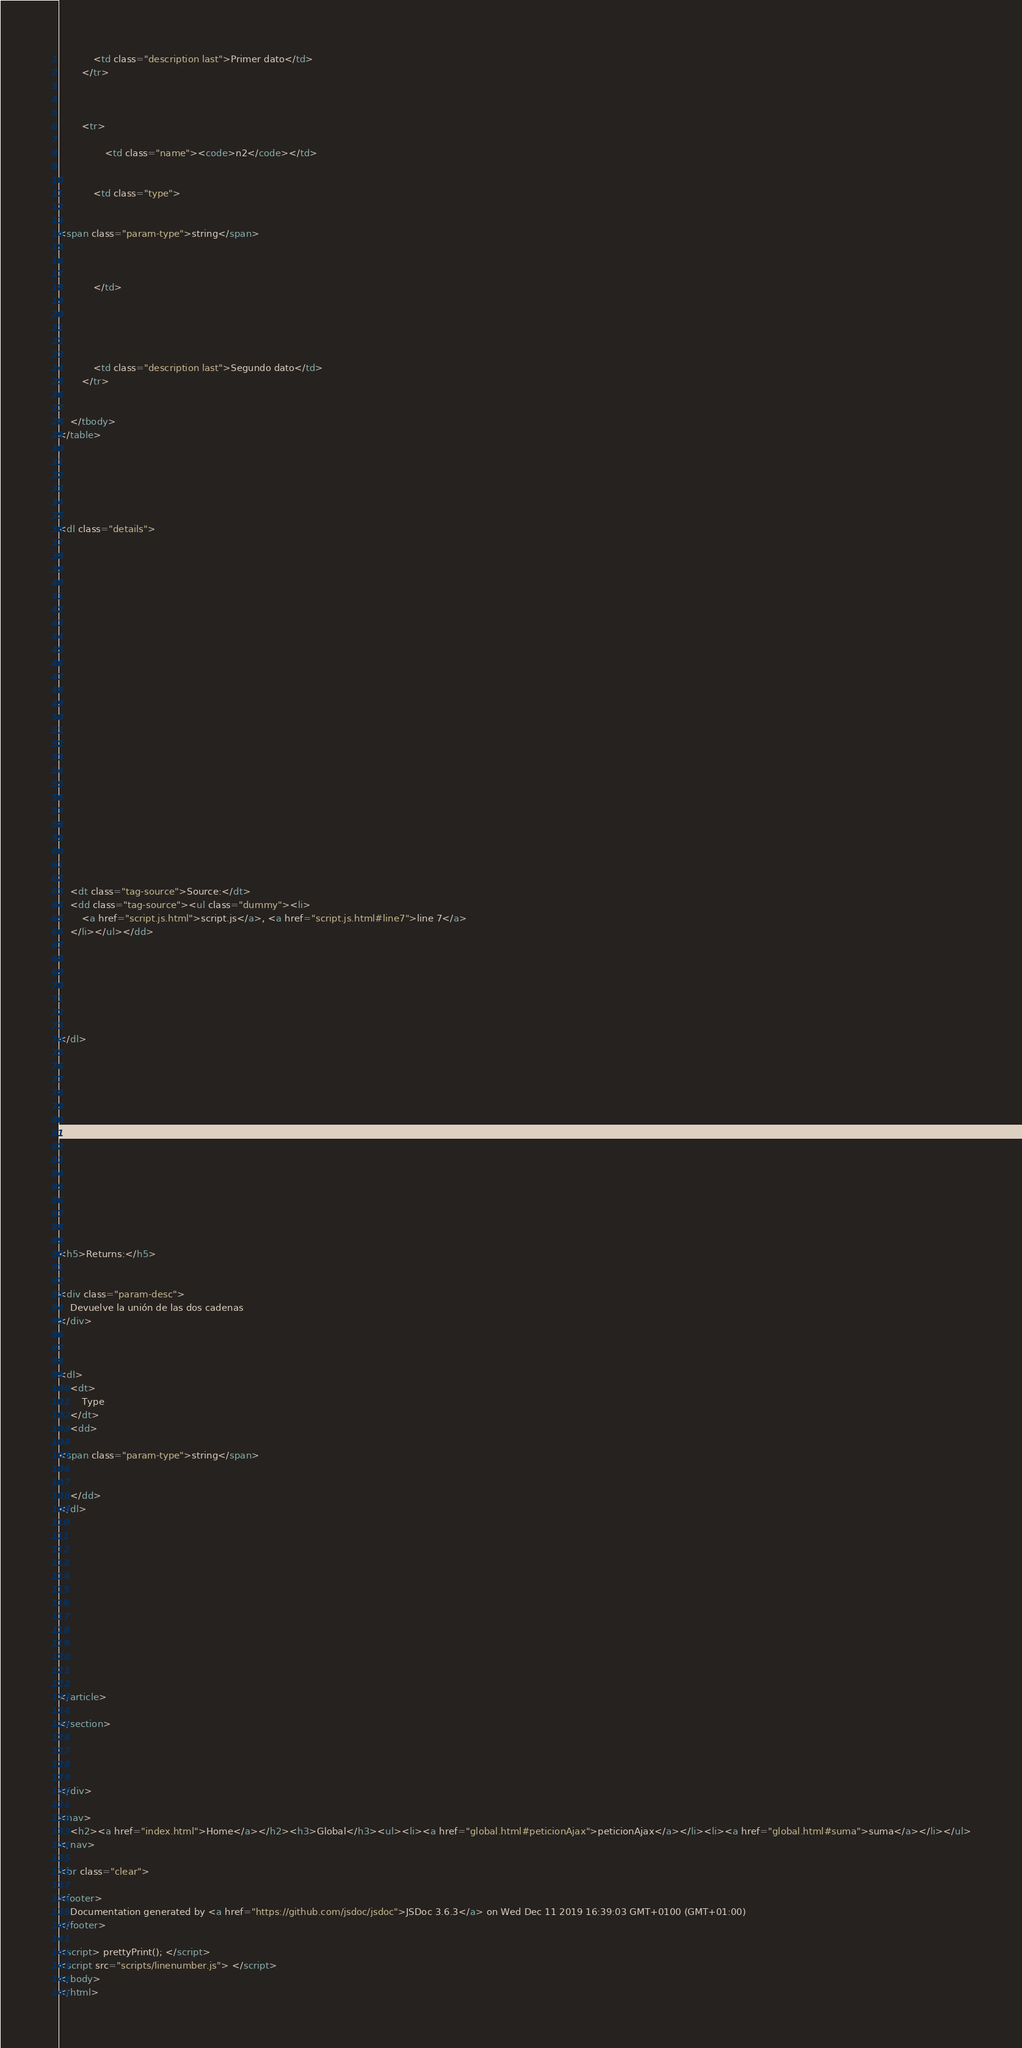<code> <loc_0><loc_0><loc_500><loc_500><_HTML_>
            <td class="description last">Primer dato</td>
        </tr>

    

        <tr>
            
                <td class="name"><code>n2</code></td>
            

            <td class="type">
            
                
<span class="param-type">string</span>


            
            </td>

            

            

            <td class="description last">Segundo dato</td>
        </tr>

    
    </tbody>
</table>






<dl class="details">

    

    

    

    

    

    

    

    

    

    

    

    

    
    <dt class="tag-source">Source:</dt>
    <dd class="tag-source"><ul class="dummy"><li>
        <a href="script.js.html">script.js</a>, <a href="script.js.html#line7">line 7</a>
    </li></ul></dd>
    

    

    

    
</dl>















<h5>Returns:</h5>

        
<div class="param-desc">
    Devuelve la unión de las dos cadenas
</div>



<dl>
    <dt>
        Type
    </dt>
    <dd>
        
<span class="param-type">string</span>


    </dd>
</dl>

    





        
    

    

    
</article>

</section>




</div>

<nav>
    <h2><a href="index.html">Home</a></h2><h3>Global</h3><ul><li><a href="global.html#peticionAjax">peticionAjax</a></li><li><a href="global.html#suma">suma</a></li></ul>
</nav>

<br class="clear">

<footer>
    Documentation generated by <a href="https://github.com/jsdoc/jsdoc">JSDoc 3.6.3</a> on Wed Dec 11 2019 16:39:03 GMT+0100 (GMT+01:00)
</footer>

<script> prettyPrint(); </script>
<script src="scripts/linenumber.js"> </script>
</body>
</html></code> 